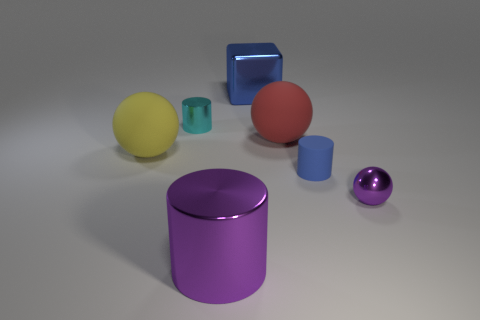Is there a predominant color scheme in this composition? The image features a mix of colors, with no single color dominating. The objects are variously colored in yellow, red, blue, and shades of purple and teal, set against a neutral gray background. 